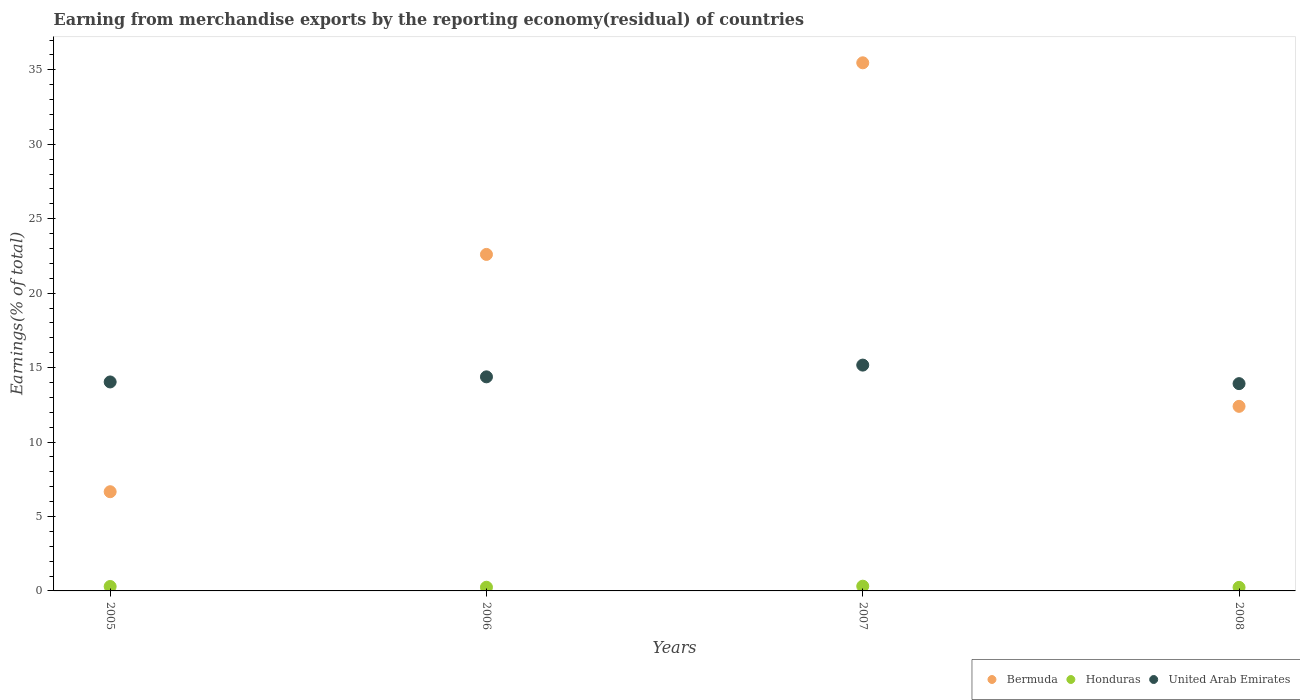How many different coloured dotlines are there?
Your answer should be very brief. 3. Is the number of dotlines equal to the number of legend labels?
Your answer should be very brief. Yes. What is the percentage of amount earned from merchandise exports in United Arab Emirates in 2005?
Offer a terse response. 14.04. Across all years, what is the maximum percentage of amount earned from merchandise exports in United Arab Emirates?
Your answer should be compact. 15.17. Across all years, what is the minimum percentage of amount earned from merchandise exports in Bermuda?
Make the answer very short. 6.66. In which year was the percentage of amount earned from merchandise exports in Honduras minimum?
Ensure brevity in your answer.  2008. What is the total percentage of amount earned from merchandise exports in Bermuda in the graph?
Ensure brevity in your answer.  77.13. What is the difference between the percentage of amount earned from merchandise exports in Honduras in 2005 and that in 2007?
Provide a succinct answer. -0.02. What is the difference between the percentage of amount earned from merchandise exports in Honduras in 2006 and the percentage of amount earned from merchandise exports in United Arab Emirates in 2007?
Offer a very short reply. -14.92. What is the average percentage of amount earned from merchandise exports in Honduras per year?
Make the answer very short. 0.28. In the year 2005, what is the difference between the percentage of amount earned from merchandise exports in Bermuda and percentage of amount earned from merchandise exports in United Arab Emirates?
Offer a very short reply. -7.37. What is the ratio of the percentage of amount earned from merchandise exports in Honduras in 2006 to that in 2008?
Ensure brevity in your answer.  1.04. What is the difference between the highest and the second highest percentage of amount earned from merchandise exports in Bermuda?
Make the answer very short. 12.87. What is the difference between the highest and the lowest percentage of amount earned from merchandise exports in Honduras?
Your answer should be compact. 0.08. Is the sum of the percentage of amount earned from merchandise exports in Honduras in 2005 and 2008 greater than the maximum percentage of amount earned from merchandise exports in Bermuda across all years?
Provide a short and direct response. No. Is it the case that in every year, the sum of the percentage of amount earned from merchandise exports in Bermuda and percentage of amount earned from merchandise exports in United Arab Emirates  is greater than the percentage of amount earned from merchandise exports in Honduras?
Your response must be concise. Yes. Does the percentage of amount earned from merchandise exports in United Arab Emirates monotonically increase over the years?
Provide a succinct answer. No. Is the percentage of amount earned from merchandise exports in Bermuda strictly less than the percentage of amount earned from merchandise exports in United Arab Emirates over the years?
Give a very brief answer. No. How many dotlines are there?
Offer a very short reply. 3. Are the values on the major ticks of Y-axis written in scientific E-notation?
Your response must be concise. No. How many legend labels are there?
Give a very brief answer. 3. What is the title of the graph?
Keep it short and to the point. Earning from merchandise exports by the reporting economy(residual) of countries. What is the label or title of the X-axis?
Your answer should be compact. Years. What is the label or title of the Y-axis?
Your answer should be very brief. Earnings(% of total). What is the Earnings(% of total) of Bermuda in 2005?
Give a very brief answer. 6.66. What is the Earnings(% of total) in Honduras in 2005?
Provide a succinct answer. 0.3. What is the Earnings(% of total) in United Arab Emirates in 2005?
Provide a succinct answer. 14.04. What is the Earnings(% of total) in Bermuda in 2006?
Provide a succinct answer. 22.6. What is the Earnings(% of total) in Honduras in 2006?
Your response must be concise. 0.25. What is the Earnings(% of total) in United Arab Emirates in 2006?
Your response must be concise. 14.38. What is the Earnings(% of total) of Bermuda in 2007?
Keep it short and to the point. 35.47. What is the Earnings(% of total) of Honduras in 2007?
Keep it short and to the point. 0.32. What is the Earnings(% of total) of United Arab Emirates in 2007?
Your response must be concise. 15.17. What is the Earnings(% of total) of Bermuda in 2008?
Give a very brief answer. 12.4. What is the Earnings(% of total) in Honduras in 2008?
Ensure brevity in your answer.  0.24. What is the Earnings(% of total) in United Arab Emirates in 2008?
Make the answer very short. 13.92. Across all years, what is the maximum Earnings(% of total) in Bermuda?
Your response must be concise. 35.47. Across all years, what is the maximum Earnings(% of total) of Honduras?
Provide a succinct answer. 0.32. Across all years, what is the maximum Earnings(% of total) of United Arab Emirates?
Your answer should be very brief. 15.17. Across all years, what is the minimum Earnings(% of total) in Bermuda?
Keep it short and to the point. 6.66. Across all years, what is the minimum Earnings(% of total) in Honduras?
Provide a short and direct response. 0.24. Across all years, what is the minimum Earnings(% of total) of United Arab Emirates?
Provide a succinct answer. 13.92. What is the total Earnings(% of total) of Bermuda in the graph?
Ensure brevity in your answer.  77.13. What is the total Earnings(% of total) of Honduras in the graph?
Provide a short and direct response. 1.1. What is the total Earnings(% of total) in United Arab Emirates in the graph?
Your answer should be very brief. 57.51. What is the difference between the Earnings(% of total) in Bermuda in 2005 and that in 2006?
Ensure brevity in your answer.  -15.94. What is the difference between the Earnings(% of total) in Honduras in 2005 and that in 2006?
Your answer should be very brief. 0.05. What is the difference between the Earnings(% of total) of United Arab Emirates in 2005 and that in 2006?
Your answer should be very brief. -0.34. What is the difference between the Earnings(% of total) in Bermuda in 2005 and that in 2007?
Make the answer very short. -28.81. What is the difference between the Earnings(% of total) of Honduras in 2005 and that in 2007?
Provide a succinct answer. -0.02. What is the difference between the Earnings(% of total) in United Arab Emirates in 2005 and that in 2007?
Your answer should be compact. -1.13. What is the difference between the Earnings(% of total) in Bermuda in 2005 and that in 2008?
Make the answer very short. -5.73. What is the difference between the Earnings(% of total) in Honduras in 2005 and that in 2008?
Provide a succinct answer. 0.06. What is the difference between the Earnings(% of total) in United Arab Emirates in 2005 and that in 2008?
Provide a succinct answer. 0.11. What is the difference between the Earnings(% of total) of Bermuda in 2006 and that in 2007?
Give a very brief answer. -12.87. What is the difference between the Earnings(% of total) of Honduras in 2006 and that in 2007?
Keep it short and to the point. -0.07. What is the difference between the Earnings(% of total) in United Arab Emirates in 2006 and that in 2007?
Give a very brief answer. -0.79. What is the difference between the Earnings(% of total) of Bermuda in 2006 and that in 2008?
Provide a short and direct response. 10.2. What is the difference between the Earnings(% of total) of Honduras in 2006 and that in 2008?
Offer a very short reply. 0.01. What is the difference between the Earnings(% of total) in United Arab Emirates in 2006 and that in 2008?
Offer a very short reply. 0.46. What is the difference between the Earnings(% of total) of Bermuda in 2007 and that in 2008?
Your response must be concise. 23.07. What is the difference between the Earnings(% of total) in Honduras in 2007 and that in 2008?
Ensure brevity in your answer.  0.08. What is the difference between the Earnings(% of total) in United Arab Emirates in 2007 and that in 2008?
Your answer should be compact. 1.25. What is the difference between the Earnings(% of total) of Bermuda in 2005 and the Earnings(% of total) of Honduras in 2006?
Offer a terse response. 6.42. What is the difference between the Earnings(% of total) in Bermuda in 2005 and the Earnings(% of total) in United Arab Emirates in 2006?
Give a very brief answer. -7.72. What is the difference between the Earnings(% of total) in Honduras in 2005 and the Earnings(% of total) in United Arab Emirates in 2006?
Offer a terse response. -14.08. What is the difference between the Earnings(% of total) of Bermuda in 2005 and the Earnings(% of total) of Honduras in 2007?
Provide a short and direct response. 6.35. What is the difference between the Earnings(% of total) of Bermuda in 2005 and the Earnings(% of total) of United Arab Emirates in 2007?
Provide a succinct answer. -8.5. What is the difference between the Earnings(% of total) of Honduras in 2005 and the Earnings(% of total) of United Arab Emirates in 2007?
Your response must be concise. -14.87. What is the difference between the Earnings(% of total) of Bermuda in 2005 and the Earnings(% of total) of Honduras in 2008?
Offer a terse response. 6.42. What is the difference between the Earnings(% of total) in Bermuda in 2005 and the Earnings(% of total) in United Arab Emirates in 2008?
Offer a very short reply. -7.26. What is the difference between the Earnings(% of total) of Honduras in 2005 and the Earnings(% of total) of United Arab Emirates in 2008?
Offer a very short reply. -13.62. What is the difference between the Earnings(% of total) in Bermuda in 2006 and the Earnings(% of total) in Honduras in 2007?
Offer a terse response. 22.28. What is the difference between the Earnings(% of total) in Bermuda in 2006 and the Earnings(% of total) in United Arab Emirates in 2007?
Make the answer very short. 7.43. What is the difference between the Earnings(% of total) in Honduras in 2006 and the Earnings(% of total) in United Arab Emirates in 2007?
Your response must be concise. -14.92. What is the difference between the Earnings(% of total) in Bermuda in 2006 and the Earnings(% of total) in Honduras in 2008?
Keep it short and to the point. 22.36. What is the difference between the Earnings(% of total) in Bermuda in 2006 and the Earnings(% of total) in United Arab Emirates in 2008?
Offer a terse response. 8.68. What is the difference between the Earnings(% of total) of Honduras in 2006 and the Earnings(% of total) of United Arab Emirates in 2008?
Your response must be concise. -13.68. What is the difference between the Earnings(% of total) in Bermuda in 2007 and the Earnings(% of total) in Honduras in 2008?
Ensure brevity in your answer.  35.23. What is the difference between the Earnings(% of total) of Bermuda in 2007 and the Earnings(% of total) of United Arab Emirates in 2008?
Ensure brevity in your answer.  21.55. What is the difference between the Earnings(% of total) of Honduras in 2007 and the Earnings(% of total) of United Arab Emirates in 2008?
Ensure brevity in your answer.  -13.61. What is the average Earnings(% of total) in Bermuda per year?
Your answer should be compact. 19.28. What is the average Earnings(% of total) of Honduras per year?
Your answer should be very brief. 0.28. What is the average Earnings(% of total) of United Arab Emirates per year?
Keep it short and to the point. 14.38. In the year 2005, what is the difference between the Earnings(% of total) in Bermuda and Earnings(% of total) in Honduras?
Keep it short and to the point. 6.37. In the year 2005, what is the difference between the Earnings(% of total) of Bermuda and Earnings(% of total) of United Arab Emirates?
Offer a very short reply. -7.37. In the year 2005, what is the difference between the Earnings(% of total) of Honduras and Earnings(% of total) of United Arab Emirates?
Your response must be concise. -13.74. In the year 2006, what is the difference between the Earnings(% of total) in Bermuda and Earnings(% of total) in Honduras?
Give a very brief answer. 22.35. In the year 2006, what is the difference between the Earnings(% of total) of Bermuda and Earnings(% of total) of United Arab Emirates?
Offer a very short reply. 8.22. In the year 2006, what is the difference between the Earnings(% of total) in Honduras and Earnings(% of total) in United Arab Emirates?
Your answer should be very brief. -14.13. In the year 2007, what is the difference between the Earnings(% of total) in Bermuda and Earnings(% of total) in Honduras?
Ensure brevity in your answer.  35.15. In the year 2007, what is the difference between the Earnings(% of total) of Bermuda and Earnings(% of total) of United Arab Emirates?
Your response must be concise. 20.3. In the year 2007, what is the difference between the Earnings(% of total) in Honduras and Earnings(% of total) in United Arab Emirates?
Your answer should be compact. -14.85. In the year 2008, what is the difference between the Earnings(% of total) in Bermuda and Earnings(% of total) in Honduras?
Give a very brief answer. 12.16. In the year 2008, what is the difference between the Earnings(% of total) in Bermuda and Earnings(% of total) in United Arab Emirates?
Your answer should be compact. -1.53. In the year 2008, what is the difference between the Earnings(% of total) in Honduras and Earnings(% of total) in United Arab Emirates?
Keep it short and to the point. -13.68. What is the ratio of the Earnings(% of total) in Bermuda in 2005 to that in 2006?
Offer a very short reply. 0.29. What is the ratio of the Earnings(% of total) in Honduras in 2005 to that in 2006?
Offer a very short reply. 1.2. What is the ratio of the Earnings(% of total) in United Arab Emirates in 2005 to that in 2006?
Offer a very short reply. 0.98. What is the ratio of the Earnings(% of total) in Bermuda in 2005 to that in 2007?
Offer a terse response. 0.19. What is the ratio of the Earnings(% of total) of Honduras in 2005 to that in 2007?
Ensure brevity in your answer.  0.94. What is the ratio of the Earnings(% of total) of United Arab Emirates in 2005 to that in 2007?
Provide a short and direct response. 0.93. What is the ratio of the Earnings(% of total) in Bermuda in 2005 to that in 2008?
Your response must be concise. 0.54. What is the ratio of the Earnings(% of total) of Honduras in 2005 to that in 2008?
Offer a very short reply. 1.25. What is the ratio of the Earnings(% of total) in Bermuda in 2006 to that in 2007?
Your answer should be very brief. 0.64. What is the ratio of the Earnings(% of total) in Honduras in 2006 to that in 2007?
Offer a terse response. 0.78. What is the ratio of the Earnings(% of total) of United Arab Emirates in 2006 to that in 2007?
Ensure brevity in your answer.  0.95. What is the ratio of the Earnings(% of total) in Bermuda in 2006 to that in 2008?
Provide a short and direct response. 1.82. What is the ratio of the Earnings(% of total) of Honduras in 2006 to that in 2008?
Your response must be concise. 1.04. What is the ratio of the Earnings(% of total) in United Arab Emirates in 2006 to that in 2008?
Provide a short and direct response. 1.03. What is the ratio of the Earnings(% of total) in Bermuda in 2007 to that in 2008?
Ensure brevity in your answer.  2.86. What is the ratio of the Earnings(% of total) of Honduras in 2007 to that in 2008?
Offer a terse response. 1.33. What is the ratio of the Earnings(% of total) in United Arab Emirates in 2007 to that in 2008?
Give a very brief answer. 1.09. What is the difference between the highest and the second highest Earnings(% of total) in Bermuda?
Your response must be concise. 12.87. What is the difference between the highest and the second highest Earnings(% of total) in Honduras?
Give a very brief answer. 0.02. What is the difference between the highest and the second highest Earnings(% of total) in United Arab Emirates?
Offer a terse response. 0.79. What is the difference between the highest and the lowest Earnings(% of total) of Bermuda?
Your answer should be compact. 28.81. What is the difference between the highest and the lowest Earnings(% of total) of Honduras?
Offer a very short reply. 0.08. What is the difference between the highest and the lowest Earnings(% of total) of United Arab Emirates?
Ensure brevity in your answer.  1.25. 